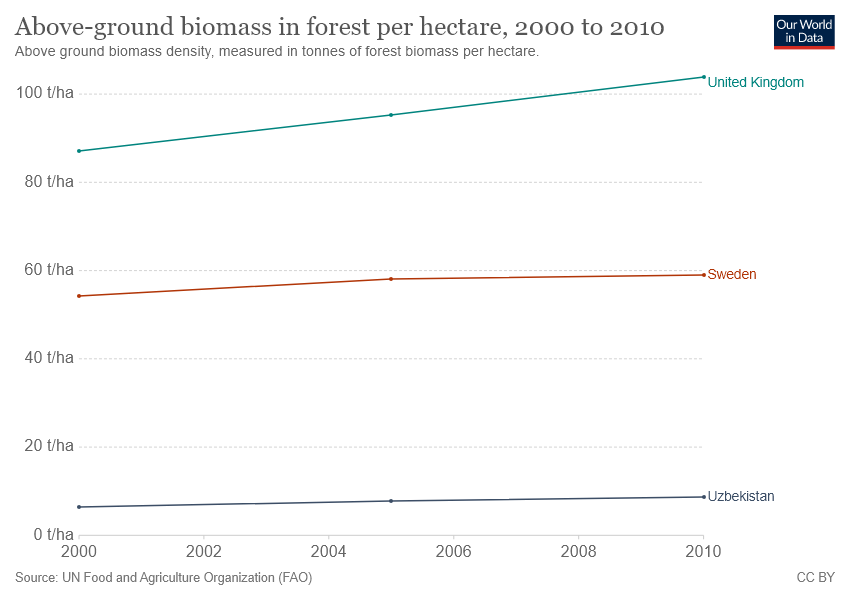Indicate a few pertinent items in this graphic. The country with a median value between 80 t/ha and 100 t/ha is the United Kingdom. The above-ground biomass in forests in the United Kingdom is increasing per hectare over the course of a year. 